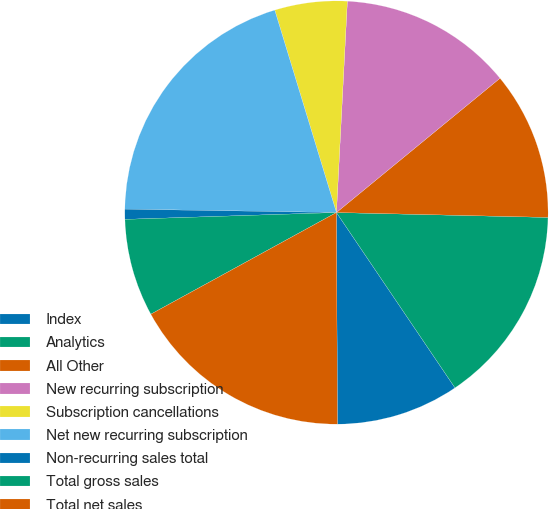<chart> <loc_0><loc_0><loc_500><loc_500><pie_chart><fcel>Index<fcel>Analytics<fcel>All Other<fcel>New recurring subscription<fcel>Subscription cancellations<fcel>Net new recurring subscription<fcel>Non-recurring sales total<fcel>Total gross sales<fcel>Total net sales<nl><fcel>9.39%<fcel>15.17%<fcel>11.31%<fcel>13.24%<fcel>5.53%<fcel>20.04%<fcel>0.77%<fcel>7.46%<fcel>17.1%<nl></chart> 